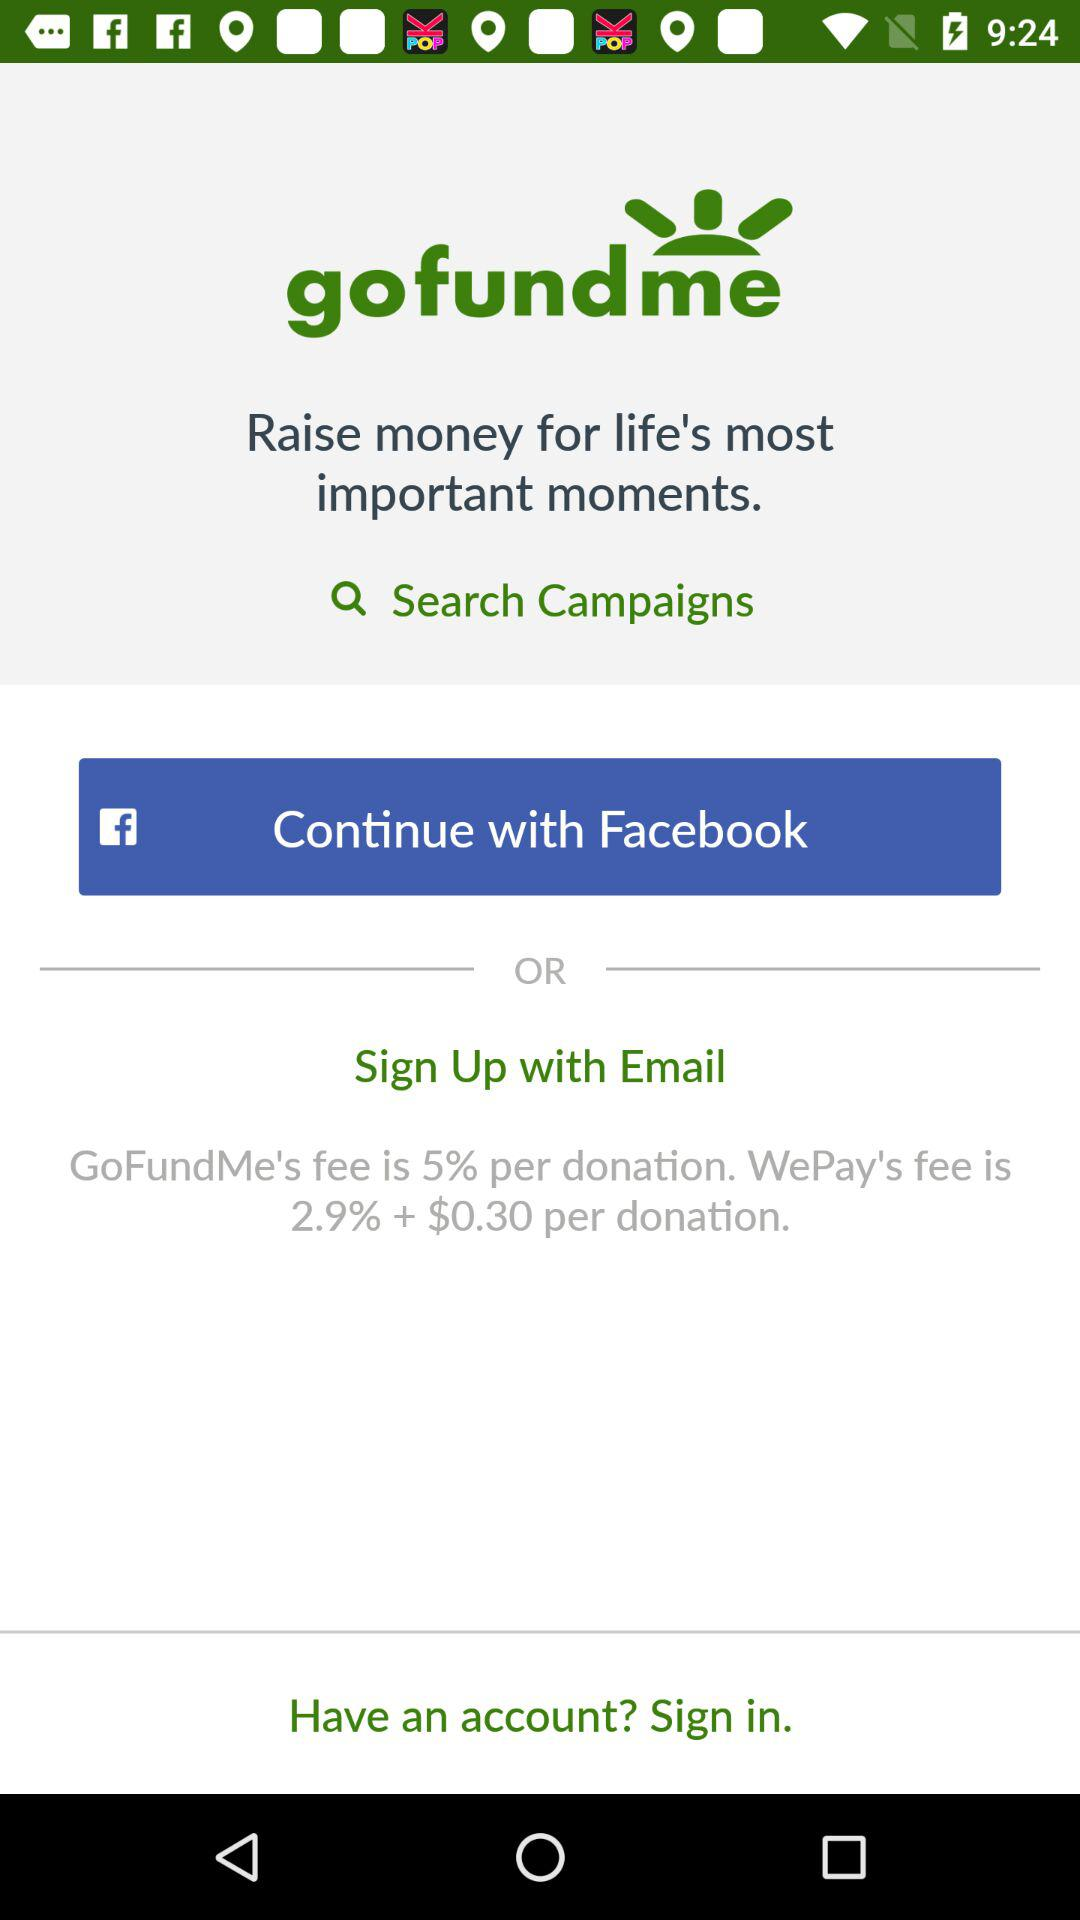What's the percentage of donations?
When the provided information is insufficient, respond with <no answer>. <no answer> 